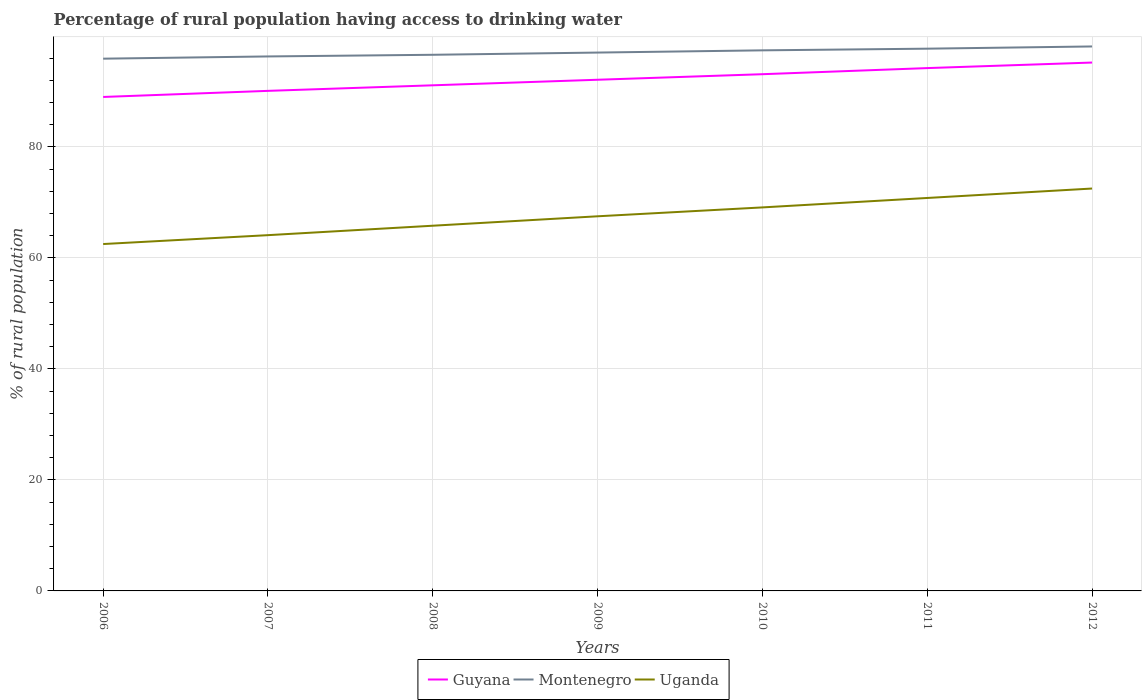Across all years, what is the maximum percentage of rural population having access to drinking water in Montenegro?
Your response must be concise. 95.9. In which year was the percentage of rural population having access to drinking water in Montenegro maximum?
Provide a succinct answer. 2006. What is the total percentage of rural population having access to drinking water in Montenegro in the graph?
Provide a short and direct response. -1.1. What is the difference between the highest and the lowest percentage of rural population having access to drinking water in Guyana?
Offer a terse response. 3. How many lines are there?
Provide a short and direct response. 3. How many years are there in the graph?
Your response must be concise. 7. Where does the legend appear in the graph?
Make the answer very short. Bottom center. What is the title of the graph?
Provide a succinct answer. Percentage of rural population having access to drinking water. Does "Botswana" appear as one of the legend labels in the graph?
Offer a terse response. No. What is the label or title of the X-axis?
Make the answer very short. Years. What is the label or title of the Y-axis?
Your answer should be very brief. % of rural population. What is the % of rural population in Guyana in 2006?
Provide a succinct answer. 89. What is the % of rural population of Montenegro in 2006?
Offer a very short reply. 95.9. What is the % of rural population of Uganda in 2006?
Provide a succinct answer. 62.5. What is the % of rural population of Guyana in 2007?
Your answer should be very brief. 90.1. What is the % of rural population of Montenegro in 2007?
Give a very brief answer. 96.3. What is the % of rural population of Uganda in 2007?
Your response must be concise. 64.1. What is the % of rural population of Guyana in 2008?
Your answer should be very brief. 91.1. What is the % of rural population in Montenegro in 2008?
Offer a very short reply. 96.6. What is the % of rural population of Uganda in 2008?
Give a very brief answer. 65.8. What is the % of rural population of Guyana in 2009?
Give a very brief answer. 92.1. What is the % of rural population in Montenegro in 2009?
Offer a very short reply. 97. What is the % of rural population in Uganda in 2009?
Provide a succinct answer. 67.5. What is the % of rural population in Guyana in 2010?
Offer a very short reply. 93.1. What is the % of rural population in Montenegro in 2010?
Keep it short and to the point. 97.4. What is the % of rural population in Uganda in 2010?
Your answer should be very brief. 69.1. What is the % of rural population of Guyana in 2011?
Keep it short and to the point. 94.2. What is the % of rural population of Montenegro in 2011?
Offer a very short reply. 97.7. What is the % of rural population in Uganda in 2011?
Keep it short and to the point. 70.8. What is the % of rural population in Guyana in 2012?
Ensure brevity in your answer.  95.2. What is the % of rural population in Montenegro in 2012?
Keep it short and to the point. 98.1. What is the % of rural population in Uganda in 2012?
Make the answer very short. 72.5. Across all years, what is the maximum % of rural population in Guyana?
Your answer should be very brief. 95.2. Across all years, what is the maximum % of rural population of Montenegro?
Your answer should be compact. 98.1. Across all years, what is the maximum % of rural population in Uganda?
Your response must be concise. 72.5. Across all years, what is the minimum % of rural population in Guyana?
Your response must be concise. 89. Across all years, what is the minimum % of rural population in Montenegro?
Make the answer very short. 95.9. Across all years, what is the minimum % of rural population in Uganda?
Your response must be concise. 62.5. What is the total % of rural population of Guyana in the graph?
Ensure brevity in your answer.  644.8. What is the total % of rural population of Montenegro in the graph?
Your answer should be compact. 679. What is the total % of rural population in Uganda in the graph?
Provide a short and direct response. 472.3. What is the difference between the % of rural population of Montenegro in 2006 and that in 2007?
Give a very brief answer. -0.4. What is the difference between the % of rural population of Montenegro in 2006 and that in 2008?
Your response must be concise. -0.7. What is the difference between the % of rural population of Uganda in 2006 and that in 2009?
Offer a very short reply. -5. What is the difference between the % of rural population in Montenegro in 2006 and that in 2010?
Offer a very short reply. -1.5. What is the difference between the % of rural population in Montenegro in 2006 and that in 2012?
Keep it short and to the point. -2.2. What is the difference between the % of rural population of Uganda in 2006 and that in 2012?
Make the answer very short. -10. What is the difference between the % of rural population of Guyana in 2007 and that in 2009?
Provide a short and direct response. -2. What is the difference between the % of rural population in Uganda in 2007 and that in 2009?
Give a very brief answer. -3.4. What is the difference between the % of rural population in Guyana in 2007 and that in 2010?
Provide a short and direct response. -3. What is the difference between the % of rural population in Guyana in 2007 and that in 2011?
Give a very brief answer. -4.1. What is the difference between the % of rural population of Montenegro in 2007 and that in 2011?
Keep it short and to the point. -1.4. What is the difference between the % of rural population in Guyana in 2007 and that in 2012?
Your response must be concise. -5.1. What is the difference between the % of rural population in Montenegro in 2007 and that in 2012?
Provide a succinct answer. -1.8. What is the difference between the % of rural population in Uganda in 2007 and that in 2012?
Your answer should be compact. -8.4. What is the difference between the % of rural population in Guyana in 2008 and that in 2009?
Your response must be concise. -1. What is the difference between the % of rural population of Montenegro in 2008 and that in 2009?
Offer a terse response. -0.4. What is the difference between the % of rural population in Uganda in 2008 and that in 2009?
Your response must be concise. -1.7. What is the difference between the % of rural population in Guyana in 2008 and that in 2010?
Make the answer very short. -2. What is the difference between the % of rural population in Montenegro in 2008 and that in 2010?
Provide a short and direct response. -0.8. What is the difference between the % of rural population of Uganda in 2008 and that in 2010?
Give a very brief answer. -3.3. What is the difference between the % of rural population in Guyana in 2008 and that in 2011?
Keep it short and to the point. -3.1. What is the difference between the % of rural population of Montenegro in 2008 and that in 2011?
Your answer should be compact. -1.1. What is the difference between the % of rural population of Guyana in 2008 and that in 2012?
Ensure brevity in your answer.  -4.1. What is the difference between the % of rural population in Uganda in 2008 and that in 2012?
Give a very brief answer. -6.7. What is the difference between the % of rural population of Guyana in 2009 and that in 2010?
Your answer should be very brief. -1. What is the difference between the % of rural population in Montenegro in 2009 and that in 2010?
Your response must be concise. -0.4. What is the difference between the % of rural population in Guyana in 2009 and that in 2011?
Your answer should be very brief. -2.1. What is the difference between the % of rural population of Uganda in 2009 and that in 2011?
Offer a very short reply. -3.3. What is the difference between the % of rural population in Guyana in 2009 and that in 2012?
Make the answer very short. -3.1. What is the difference between the % of rural population of Uganda in 2009 and that in 2012?
Ensure brevity in your answer.  -5. What is the difference between the % of rural population in Montenegro in 2010 and that in 2012?
Keep it short and to the point. -0.7. What is the difference between the % of rural population of Uganda in 2010 and that in 2012?
Provide a succinct answer. -3.4. What is the difference between the % of rural population in Montenegro in 2011 and that in 2012?
Make the answer very short. -0.4. What is the difference between the % of rural population in Guyana in 2006 and the % of rural population in Montenegro in 2007?
Offer a very short reply. -7.3. What is the difference between the % of rural population of Guyana in 2006 and the % of rural population of Uganda in 2007?
Offer a very short reply. 24.9. What is the difference between the % of rural population in Montenegro in 2006 and the % of rural population in Uganda in 2007?
Provide a short and direct response. 31.8. What is the difference between the % of rural population of Guyana in 2006 and the % of rural population of Uganda in 2008?
Give a very brief answer. 23.2. What is the difference between the % of rural population in Montenegro in 2006 and the % of rural population in Uganda in 2008?
Keep it short and to the point. 30.1. What is the difference between the % of rural population of Guyana in 2006 and the % of rural population of Uganda in 2009?
Your answer should be compact. 21.5. What is the difference between the % of rural population in Montenegro in 2006 and the % of rural population in Uganda in 2009?
Give a very brief answer. 28.4. What is the difference between the % of rural population of Guyana in 2006 and the % of rural population of Montenegro in 2010?
Provide a short and direct response. -8.4. What is the difference between the % of rural population of Guyana in 2006 and the % of rural population of Uganda in 2010?
Provide a short and direct response. 19.9. What is the difference between the % of rural population in Montenegro in 2006 and the % of rural population in Uganda in 2010?
Offer a very short reply. 26.8. What is the difference between the % of rural population in Guyana in 2006 and the % of rural population in Montenegro in 2011?
Keep it short and to the point. -8.7. What is the difference between the % of rural population of Montenegro in 2006 and the % of rural population of Uganda in 2011?
Give a very brief answer. 25.1. What is the difference between the % of rural population of Guyana in 2006 and the % of rural population of Montenegro in 2012?
Provide a short and direct response. -9.1. What is the difference between the % of rural population of Guyana in 2006 and the % of rural population of Uganda in 2012?
Provide a short and direct response. 16.5. What is the difference between the % of rural population in Montenegro in 2006 and the % of rural population in Uganda in 2012?
Your answer should be very brief. 23.4. What is the difference between the % of rural population in Guyana in 2007 and the % of rural population in Uganda in 2008?
Make the answer very short. 24.3. What is the difference between the % of rural population of Montenegro in 2007 and the % of rural population of Uganda in 2008?
Offer a terse response. 30.5. What is the difference between the % of rural population in Guyana in 2007 and the % of rural population in Montenegro in 2009?
Your response must be concise. -6.9. What is the difference between the % of rural population in Guyana in 2007 and the % of rural population in Uganda in 2009?
Provide a succinct answer. 22.6. What is the difference between the % of rural population of Montenegro in 2007 and the % of rural population of Uganda in 2009?
Give a very brief answer. 28.8. What is the difference between the % of rural population in Montenegro in 2007 and the % of rural population in Uganda in 2010?
Your response must be concise. 27.2. What is the difference between the % of rural population of Guyana in 2007 and the % of rural population of Uganda in 2011?
Your answer should be compact. 19.3. What is the difference between the % of rural population of Guyana in 2007 and the % of rural population of Uganda in 2012?
Your answer should be very brief. 17.6. What is the difference between the % of rural population of Montenegro in 2007 and the % of rural population of Uganda in 2012?
Your answer should be compact. 23.8. What is the difference between the % of rural population of Guyana in 2008 and the % of rural population of Uganda in 2009?
Keep it short and to the point. 23.6. What is the difference between the % of rural population of Montenegro in 2008 and the % of rural population of Uganda in 2009?
Provide a succinct answer. 29.1. What is the difference between the % of rural population in Guyana in 2008 and the % of rural population in Uganda in 2010?
Your answer should be compact. 22. What is the difference between the % of rural population of Montenegro in 2008 and the % of rural population of Uganda in 2010?
Make the answer very short. 27.5. What is the difference between the % of rural population of Guyana in 2008 and the % of rural population of Montenegro in 2011?
Offer a terse response. -6.6. What is the difference between the % of rural population in Guyana in 2008 and the % of rural population in Uganda in 2011?
Your answer should be very brief. 20.3. What is the difference between the % of rural population in Montenegro in 2008 and the % of rural population in Uganda in 2011?
Keep it short and to the point. 25.8. What is the difference between the % of rural population in Guyana in 2008 and the % of rural population in Montenegro in 2012?
Keep it short and to the point. -7. What is the difference between the % of rural population in Guyana in 2008 and the % of rural population in Uganda in 2012?
Make the answer very short. 18.6. What is the difference between the % of rural population of Montenegro in 2008 and the % of rural population of Uganda in 2012?
Provide a succinct answer. 24.1. What is the difference between the % of rural population of Guyana in 2009 and the % of rural population of Montenegro in 2010?
Provide a short and direct response. -5.3. What is the difference between the % of rural population in Montenegro in 2009 and the % of rural population in Uganda in 2010?
Ensure brevity in your answer.  27.9. What is the difference between the % of rural population of Guyana in 2009 and the % of rural population of Uganda in 2011?
Provide a succinct answer. 21.3. What is the difference between the % of rural population in Montenegro in 2009 and the % of rural population in Uganda in 2011?
Give a very brief answer. 26.2. What is the difference between the % of rural population of Guyana in 2009 and the % of rural population of Montenegro in 2012?
Make the answer very short. -6. What is the difference between the % of rural population in Guyana in 2009 and the % of rural population in Uganda in 2012?
Ensure brevity in your answer.  19.6. What is the difference between the % of rural population of Montenegro in 2009 and the % of rural population of Uganda in 2012?
Offer a terse response. 24.5. What is the difference between the % of rural population of Guyana in 2010 and the % of rural population of Uganda in 2011?
Give a very brief answer. 22.3. What is the difference between the % of rural population of Montenegro in 2010 and the % of rural population of Uganda in 2011?
Provide a short and direct response. 26.6. What is the difference between the % of rural population in Guyana in 2010 and the % of rural population in Uganda in 2012?
Ensure brevity in your answer.  20.6. What is the difference between the % of rural population in Montenegro in 2010 and the % of rural population in Uganda in 2012?
Make the answer very short. 24.9. What is the difference between the % of rural population of Guyana in 2011 and the % of rural population of Montenegro in 2012?
Provide a succinct answer. -3.9. What is the difference between the % of rural population in Guyana in 2011 and the % of rural population in Uganda in 2012?
Your answer should be compact. 21.7. What is the difference between the % of rural population of Montenegro in 2011 and the % of rural population of Uganda in 2012?
Make the answer very short. 25.2. What is the average % of rural population of Guyana per year?
Your answer should be compact. 92.11. What is the average % of rural population of Montenegro per year?
Provide a short and direct response. 97. What is the average % of rural population in Uganda per year?
Give a very brief answer. 67.47. In the year 2006, what is the difference between the % of rural population of Guyana and % of rural population of Montenegro?
Provide a short and direct response. -6.9. In the year 2006, what is the difference between the % of rural population of Guyana and % of rural population of Uganda?
Give a very brief answer. 26.5. In the year 2006, what is the difference between the % of rural population in Montenegro and % of rural population in Uganda?
Give a very brief answer. 33.4. In the year 2007, what is the difference between the % of rural population in Montenegro and % of rural population in Uganda?
Ensure brevity in your answer.  32.2. In the year 2008, what is the difference between the % of rural population of Guyana and % of rural population of Uganda?
Offer a terse response. 25.3. In the year 2008, what is the difference between the % of rural population in Montenegro and % of rural population in Uganda?
Provide a succinct answer. 30.8. In the year 2009, what is the difference between the % of rural population of Guyana and % of rural population of Uganda?
Your response must be concise. 24.6. In the year 2009, what is the difference between the % of rural population in Montenegro and % of rural population in Uganda?
Provide a succinct answer. 29.5. In the year 2010, what is the difference between the % of rural population of Guyana and % of rural population of Montenegro?
Offer a very short reply. -4.3. In the year 2010, what is the difference between the % of rural population of Montenegro and % of rural population of Uganda?
Ensure brevity in your answer.  28.3. In the year 2011, what is the difference between the % of rural population in Guyana and % of rural population in Uganda?
Ensure brevity in your answer.  23.4. In the year 2011, what is the difference between the % of rural population of Montenegro and % of rural population of Uganda?
Ensure brevity in your answer.  26.9. In the year 2012, what is the difference between the % of rural population of Guyana and % of rural population of Montenegro?
Offer a terse response. -2.9. In the year 2012, what is the difference between the % of rural population in Guyana and % of rural population in Uganda?
Your answer should be compact. 22.7. In the year 2012, what is the difference between the % of rural population in Montenegro and % of rural population in Uganda?
Your answer should be compact. 25.6. What is the ratio of the % of rural population of Guyana in 2006 to that in 2007?
Keep it short and to the point. 0.99. What is the ratio of the % of rural population in Montenegro in 2006 to that in 2007?
Provide a succinct answer. 1. What is the ratio of the % of rural population in Uganda in 2006 to that in 2007?
Your answer should be very brief. 0.97. What is the ratio of the % of rural population of Guyana in 2006 to that in 2008?
Offer a very short reply. 0.98. What is the ratio of the % of rural population of Montenegro in 2006 to that in 2008?
Ensure brevity in your answer.  0.99. What is the ratio of the % of rural population in Uganda in 2006 to that in 2008?
Offer a very short reply. 0.95. What is the ratio of the % of rural population in Guyana in 2006 to that in 2009?
Ensure brevity in your answer.  0.97. What is the ratio of the % of rural population of Montenegro in 2006 to that in 2009?
Offer a terse response. 0.99. What is the ratio of the % of rural population of Uganda in 2006 to that in 2009?
Provide a short and direct response. 0.93. What is the ratio of the % of rural population in Guyana in 2006 to that in 2010?
Give a very brief answer. 0.96. What is the ratio of the % of rural population of Montenegro in 2006 to that in 2010?
Offer a very short reply. 0.98. What is the ratio of the % of rural population in Uganda in 2006 to that in 2010?
Ensure brevity in your answer.  0.9. What is the ratio of the % of rural population of Guyana in 2006 to that in 2011?
Your response must be concise. 0.94. What is the ratio of the % of rural population in Montenegro in 2006 to that in 2011?
Provide a short and direct response. 0.98. What is the ratio of the % of rural population in Uganda in 2006 to that in 2011?
Ensure brevity in your answer.  0.88. What is the ratio of the % of rural population of Guyana in 2006 to that in 2012?
Ensure brevity in your answer.  0.93. What is the ratio of the % of rural population in Montenegro in 2006 to that in 2012?
Make the answer very short. 0.98. What is the ratio of the % of rural population in Uganda in 2006 to that in 2012?
Offer a terse response. 0.86. What is the ratio of the % of rural population in Guyana in 2007 to that in 2008?
Make the answer very short. 0.99. What is the ratio of the % of rural population of Montenegro in 2007 to that in 2008?
Your answer should be compact. 1. What is the ratio of the % of rural population of Uganda in 2007 to that in 2008?
Provide a short and direct response. 0.97. What is the ratio of the % of rural population in Guyana in 2007 to that in 2009?
Make the answer very short. 0.98. What is the ratio of the % of rural population in Montenegro in 2007 to that in 2009?
Ensure brevity in your answer.  0.99. What is the ratio of the % of rural population of Uganda in 2007 to that in 2009?
Keep it short and to the point. 0.95. What is the ratio of the % of rural population of Guyana in 2007 to that in 2010?
Your answer should be compact. 0.97. What is the ratio of the % of rural population of Montenegro in 2007 to that in 2010?
Your response must be concise. 0.99. What is the ratio of the % of rural population of Uganda in 2007 to that in 2010?
Keep it short and to the point. 0.93. What is the ratio of the % of rural population in Guyana in 2007 to that in 2011?
Provide a succinct answer. 0.96. What is the ratio of the % of rural population in Montenegro in 2007 to that in 2011?
Ensure brevity in your answer.  0.99. What is the ratio of the % of rural population in Uganda in 2007 to that in 2011?
Offer a very short reply. 0.91. What is the ratio of the % of rural population of Guyana in 2007 to that in 2012?
Your answer should be compact. 0.95. What is the ratio of the % of rural population in Montenegro in 2007 to that in 2012?
Offer a terse response. 0.98. What is the ratio of the % of rural population of Uganda in 2007 to that in 2012?
Provide a succinct answer. 0.88. What is the ratio of the % of rural population of Montenegro in 2008 to that in 2009?
Ensure brevity in your answer.  1. What is the ratio of the % of rural population in Uganda in 2008 to that in 2009?
Keep it short and to the point. 0.97. What is the ratio of the % of rural population in Guyana in 2008 to that in 2010?
Ensure brevity in your answer.  0.98. What is the ratio of the % of rural population of Uganda in 2008 to that in 2010?
Make the answer very short. 0.95. What is the ratio of the % of rural population of Guyana in 2008 to that in 2011?
Make the answer very short. 0.97. What is the ratio of the % of rural population in Montenegro in 2008 to that in 2011?
Your answer should be compact. 0.99. What is the ratio of the % of rural population of Uganda in 2008 to that in 2011?
Ensure brevity in your answer.  0.93. What is the ratio of the % of rural population of Guyana in 2008 to that in 2012?
Your answer should be very brief. 0.96. What is the ratio of the % of rural population of Montenegro in 2008 to that in 2012?
Keep it short and to the point. 0.98. What is the ratio of the % of rural population in Uganda in 2008 to that in 2012?
Give a very brief answer. 0.91. What is the ratio of the % of rural population in Guyana in 2009 to that in 2010?
Offer a very short reply. 0.99. What is the ratio of the % of rural population in Uganda in 2009 to that in 2010?
Offer a terse response. 0.98. What is the ratio of the % of rural population of Guyana in 2009 to that in 2011?
Your answer should be compact. 0.98. What is the ratio of the % of rural population of Uganda in 2009 to that in 2011?
Your answer should be compact. 0.95. What is the ratio of the % of rural population in Guyana in 2009 to that in 2012?
Keep it short and to the point. 0.97. What is the ratio of the % of rural population of Montenegro in 2009 to that in 2012?
Ensure brevity in your answer.  0.99. What is the ratio of the % of rural population in Guyana in 2010 to that in 2011?
Offer a very short reply. 0.99. What is the ratio of the % of rural population of Montenegro in 2010 to that in 2011?
Offer a terse response. 1. What is the ratio of the % of rural population in Uganda in 2010 to that in 2011?
Make the answer very short. 0.98. What is the ratio of the % of rural population of Guyana in 2010 to that in 2012?
Give a very brief answer. 0.98. What is the ratio of the % of rural population of Montenegro in 2010 to that in 2012?
Your response must be concise. 0.99. What is the ratio of the % of rural population of Uganda in 2010 to that in 2012?
Offer a terse response. 0.95. What is the ratio of the % of rural population of Guyana in 2011 to that in 2012?
Keep it short and to the point. 0.99. What is the ratio of the % of rural population of Montenegro in 2011 to that in 2012?
Make the answer very short. 1. What is the ratio of the % of rural population of Uganda in 2011 to that in 2012?
Make the answer very short. 0.98. What is the difference between the highest and the lowest % of rural population in Montenegro?
Your answer should be very brief. 2.2. 